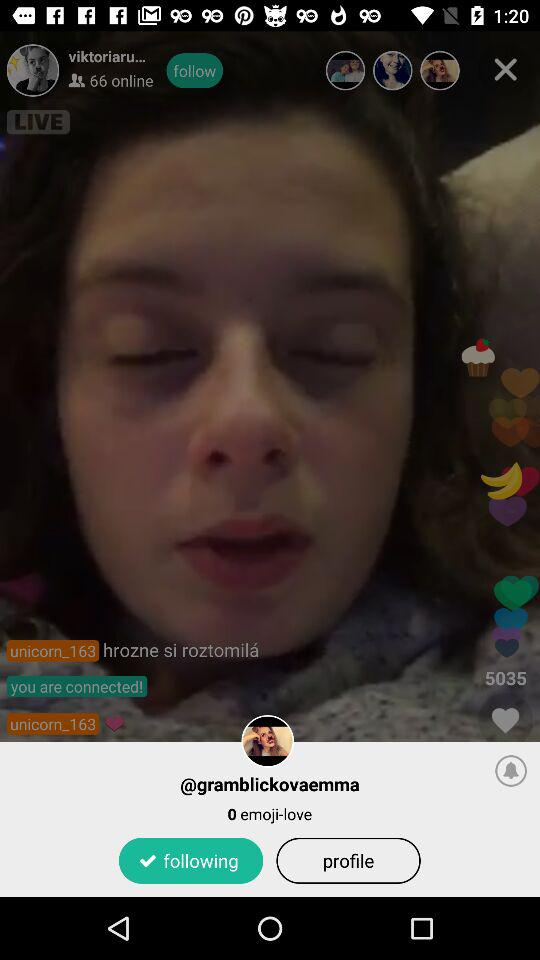How many likes are there on the post? There are 5035 likes. 